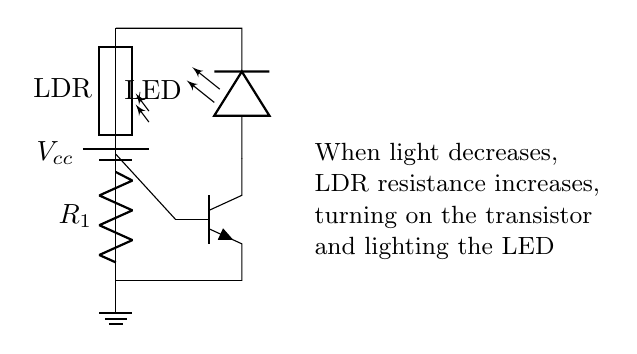What type of transistor is used in this circuit? The circuit diagram specifies a npn transistor, which can be identified by the symbol shown. The shape and orientation of the terminals indicate it is a bipolar junction transistor, specifically configured for this application.
Answer: npn What component detects light levels? The photoresistor, often referred to as LDR, acts as the light sensor in this circuit. It changes resistance based on the light intensity, affecting the circuit's operation.
Answer: LDR What happens to the LED when light levels decrease? As light decreases, the resistance of the LDR increases, causing the transistor to turn on and allowing current to flow through the LED, thus lighting it up.
Answer: LED turns on What is the role of resistor R1 in this circuit? R1 is used to limit the current flowing through the LDR, protecting it and the transistor from excessive current. It helps ensure the appropriate operation of the light-sensing mechanism.
Answer: Current limiter How does the transistor affect the operation of the LED? The transistor acts as a switch in this circuit. When the LDR detects low light, its increased resistance turns on the transistor, allowing current to flow through the LED. Thus, the transistor controls whether the LED is on or off.
Answer: Acts as a switch What is the purpose of the battery in this circuit? The battery provides the necessary voltage and current to power the entire circuit. It is the source of energy that allows the components to function correctly and enables the LED to light when the conditions are met.
Answer: Power source 